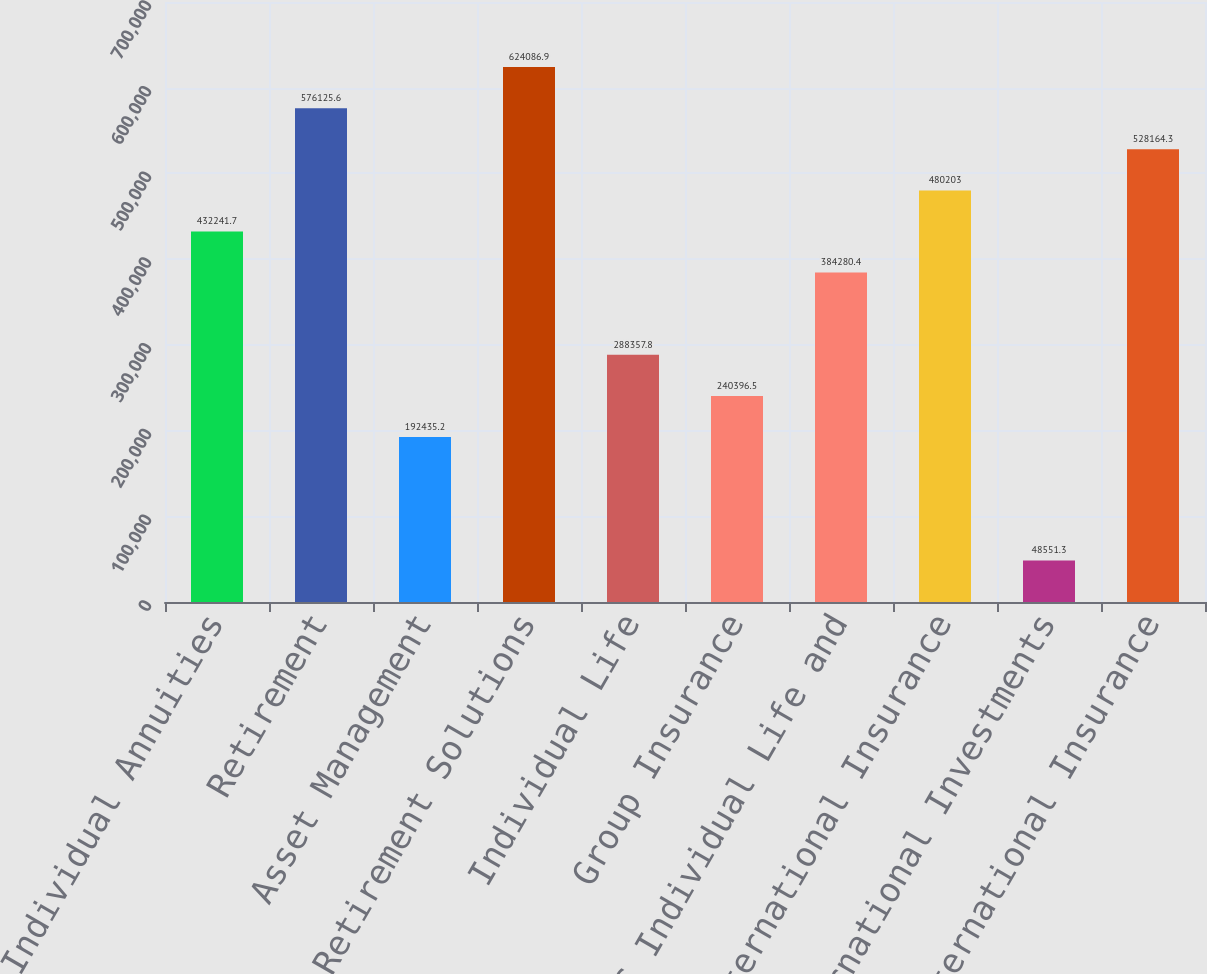Convert chart to OTSL. <chart><loc_0><loc_0><loc_500><loc_500><bar_chart><fcel>Individual Annuities<fcel>Retirement<fcel>Asset Management<fcel>Total US Retirement Solutions<fcel>Individual Life<fcel>Group Insurance<fcel>Total US Individual Life and<fcel>International Insurance<fcel>International Investments<fcel>Total International Insurance<nl><fcel>432242<fcel>576126<fcel>192435<fcel>624087<fcel>288358<fcel>240396<fcel>384280<fcel>480203<fcel>48551.3<fcel>528164<nl></chart> 